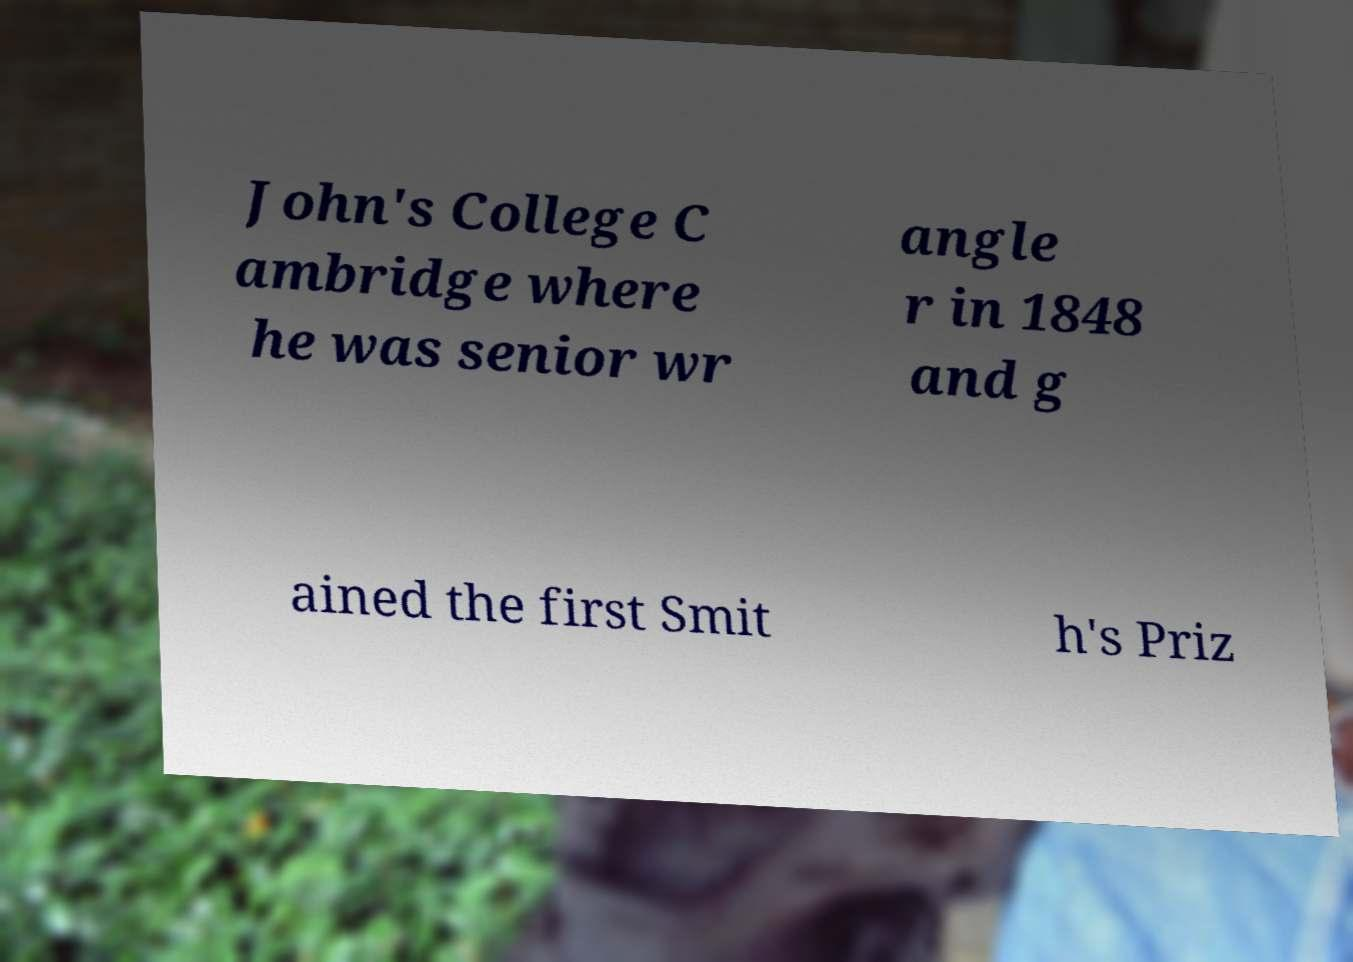There's text embedded in this image that I need extracted. Can you transcribe it verbatim? John's College C ambridge where he was senior wr angle r in 1848 and g ained the first Smit h's Priz 